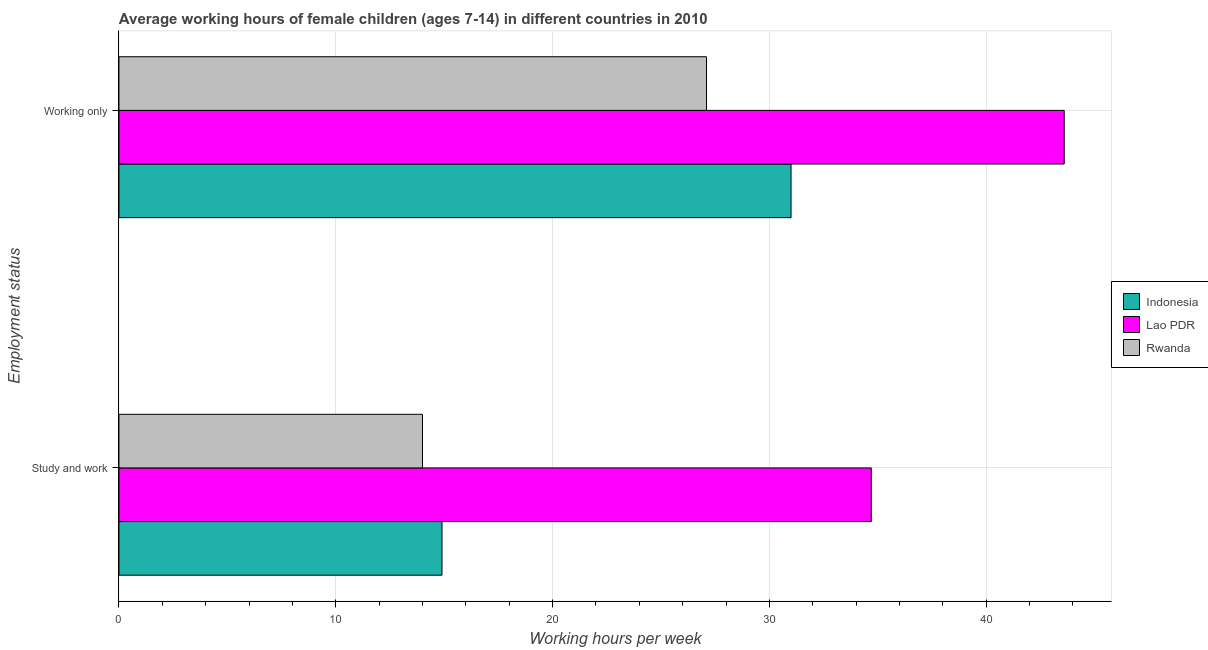How many different coloured bars are there?
Keep it short and to the point. 3. How many bars are there on the 2nd tick from the top?
Your response must be concise. 3. How many bars are there on the 2nd tick from the bottom?
Provide a succinct answer. 3. What is the label of the 1st group of bars from the top?
Make the answer very short. Working only. What is the average working hour of children involved in study and work in Lao PDR?
Offer a very short reply. 34.7. Across all countries, what is the maximum average working hour of children involved in study and work?
Your response must be concise. 34.7. In which country was the average working hour of children involved in study and work maximum?
Ensure brevity in your answer.  Lao PDR. In which country was the average working hour of children involved in study and work minimum?
Your response must be concise. Rwanda. What is the total average working hour of children involved in only work in the graph?
Provide a short and direct response. 101.7. What is the difference between the average working hour of children involved in only work in Lao PDR and that in Rwanda?
Provide a succinct answer. 16.5. What is the difference between the average working hour of children involved in study and work in Indonesia and the average working hour of children involved in only work in Rwanda?
Provide a succinct answer. -12.2. What is the average average working hour of children involved in study and work per country?
Offer a terse response. 21.2. What is the difference between the average working hour of children involved in only work and average working hour of children involved in study and work in Rwanda?
Give a very brief answer. 13.1. What is the ratio of the average working hour of children involved in study and work in Indonesia to that in Lao PDR?
Give a very brief answer. 0.43. In how many countries, is the average working hour of children involved in only work greater than the average average working hour of children involved in only work taken over all countries?
Make the answer very short. 1. What does the 1st bar from the bottom in Study and work represents?
Provide a succinct answer. Indonesia. Are all the bars in the graph horizontal?
Ensure brevity in your answer.  Yes. How many countries are there in the graph?
Offer a very short reply. 3. What is the title of the graph?
Provide a succinct answer. Average working hours of female children (ages 7-14) in different countries in 2010. Does "South Asia" appear as one of the legend labels in the graph?
Provide a short and direct response. No. What is the label or title of the X-axis?
Give a very brief answer. Working hours per week. What is the label or title of the Y-axis?
Offer a terse response. Employment status. What is the Working hours per week in Lao PDR in Study and work?
Provide a short and direct response. 34.7. What is the Working hours per week of Rwanda in Study and work?
Provide a short and direct response. 14. What is the Working hours per week in Lao PDR in Working only?
Your answer should be very brief. 43.6. What is the Working hours per week in Rwanda in Working only?
Give a very brief answer. 27.1. Across all Employment status, what is the maximum Working hours per week of Indonesia?
Give a very brief answer. 31. Across all Employment status, what is the maximum Working hours per week of Lao PDR?
Provide a succinct answer. 43.6. Across all Employment status, what is the maximum Working hours per week in Rwanda?
Your response must be concise. 27.1. Across all Employment status, what is the minimum Working hours per week in Lao PDR?
Ensure brevity in your answer.  34.7. Across all Employment status, what is the minimum Working hours per week in Rwanda?
Your response must be concise. 14. What is the total Working hours per week of Indonesia in the graph?
Make the answer very short. 45.9. What is the total Working hours per week in Lao PDR in the graph?
Offer a terse response. 78.3. What is the total Working hours per week of Rwanda in the graph?
Your answer should be very brief. 41.1. What is the difference between the Working hours per week of Indonesia in Study and work and that in Working only?
Provide a short and direct response. -16.1. What is the difference between the Working hours per week of Lao PDR in Study and work and that in Working only?
Offer a very short reply. -8.9. What is the difference between the Working hours per week of Rwanda in Study and work and that in Working only?
Your response must be concise. -13.1. What is the difference between the Working hours per week in Indonesia in Study and work and the Working hours per week in Lao PDR in Working only?
Keep it short and to the point. -28.7. What is the difference between the Working hours per week in Indonesia in Study and work and the Working hours per week in Rwanda in Working only?
Provide a short and direct response. -12.2. What is the average Working hours per week in Indonesia per Employment status?
Offer a very short reply. 22.95. What is the average Working hours per week of Lao PDR per Employment status?
Your answer should be compact. 39.15. What is the average Working hours per week in Rwanda per Employment status?
Your answer should be very brief. 20.55. What is the difference between the Working hours per week in Indonesia and Working hours per week in Lao PDR in Study and work?
Your answer should be compact. -19.8. What is the difference between the Working hours per week of Lao PDR and Working hours per week of Rwanda in Study and work?
Offer a terse response. 20.7. What is the difference between the Working hours per week of Indonesia and Working hours per week of Lao PDR in Working only?
Give a very brief answer. -12.6. What is the difference between the Working hours per week in Lao PDR and Working hours per week in Rwanda in Working only?
Provide a short and direct response. 16.5. What is the ratio of the Working hours per week in Indonesia in Study and work to that in Working only?
Your answer should be very brief. 0.48. What is the ratio of the Working hours per week of Lao PDR in Study and work to that in Working only?
Ensure brevity in your answer.  0.8. What is the ratio of the Working hours per week of Rwanda in Study and work to that in Working only?
Give a very brief answer. 0.52. What is the difference between the highest and the second highest Working hours per week of Rwanda?
Keep it short and to the point. 13.1. What is the difference between the highest and the lowest Working hours per week in Indonesia?
Provide a succinct answer. 16.1. What is the difference between the highest and the lowest Working hours per week in Lao PDR?
Offer a very short reply. 8.9. 